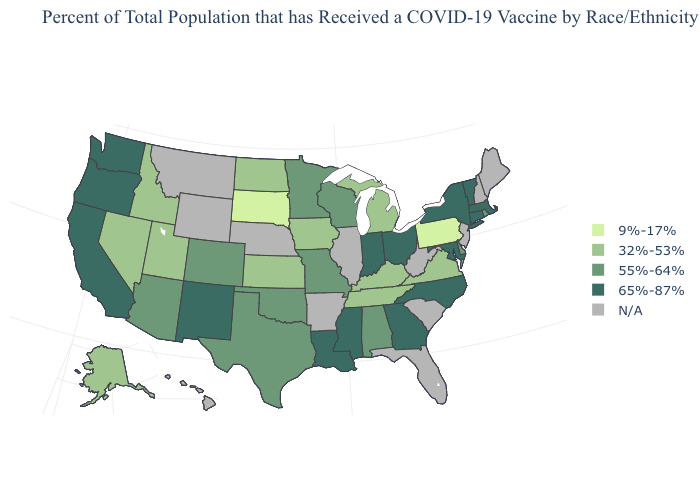Does Massachusetts have the highest value in the Northeast?
Write a very short answer. Yes. What is the lowest value in states that border Iowa?
Concise answer only. 9%-17%. Does the first symbol in the legend represent the smallest category?
Write a very short answer. Yes. What is the highest value in the USA?
Give a very brief answer. 65%-87%. How many symbols are there in the legend?
Short answer required. 5. What is the value of Arizona?
Short answer required. 55%-64%. Among the states that border Kansas , which have the highest value?
Quick response, please. Colorado, Missouri, Oklahoma. Which states hav the highest value in the West?
Keep it brief. California, New Mexico, Oregon, Washington. Does the first symbol in the legend represent the smallest category?
Concise answer only. Yes. What is the highest value in the USA?
Be succinct. 65%-87%. Name the states that have a value in the range 65%-87%?
Be succinct. California, Connecticut, Georgia, Indiana, Louisiana, Maryland, Massachusetts, Mississippi, New Mexico, New York, North Carolina, Ohio, Oregon, Vermont, Washington. Does Oklahoma have the highest value in the USA?
Answer briefly. No. Which states hav the highest value in the South?
Give a very brief answer. Georgia, Louisiana, Maryland, Mississippi, North Carolina. Does Indiana have the highest value in the MidWest?
Concise answer only. Yes. 